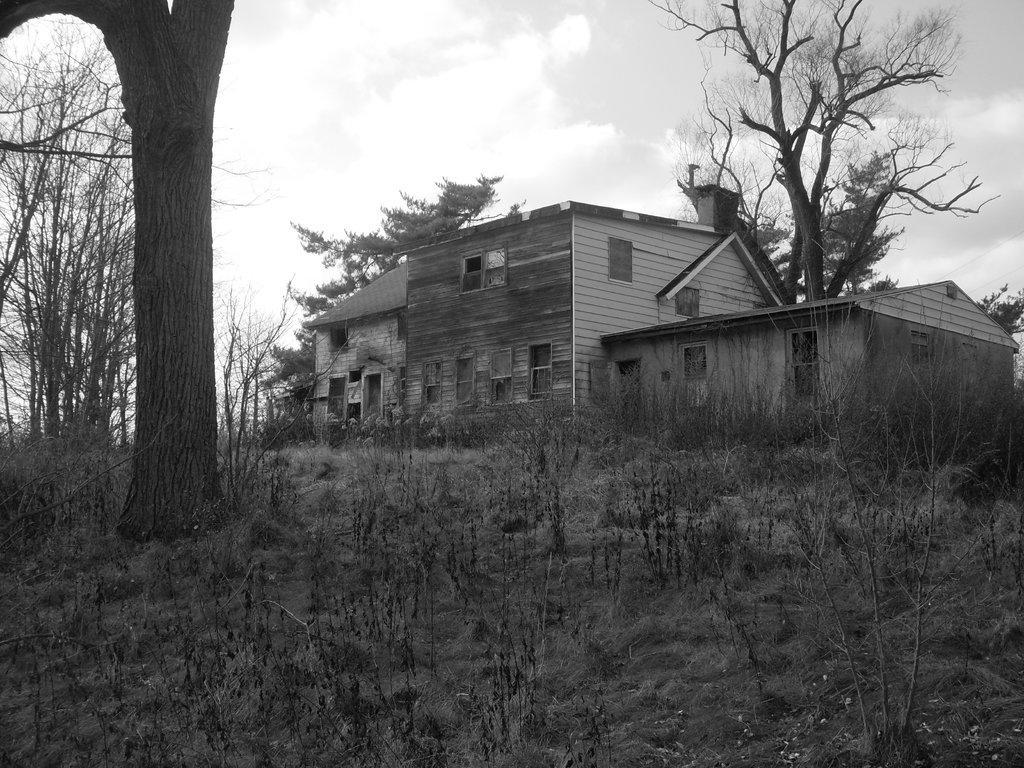Can you describe this image briefly? This is a black and white image and here we can see houses and trees. At the bottom, there is ground covered with plants and at the top, there are clouds in the sky. 